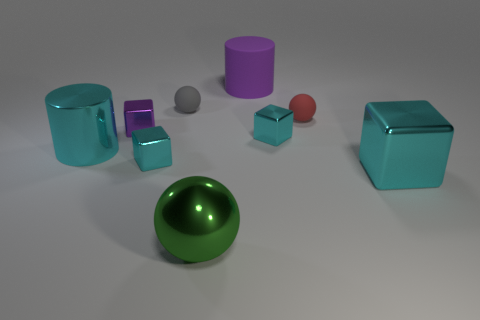Can you describe the size and color of the objects in the foreground? Certainly! In the foreground, there is a large green sphere with a reflective surface. Additionally, there's a smaller purple cylinder to its right and a tiny red sphere to its left. 